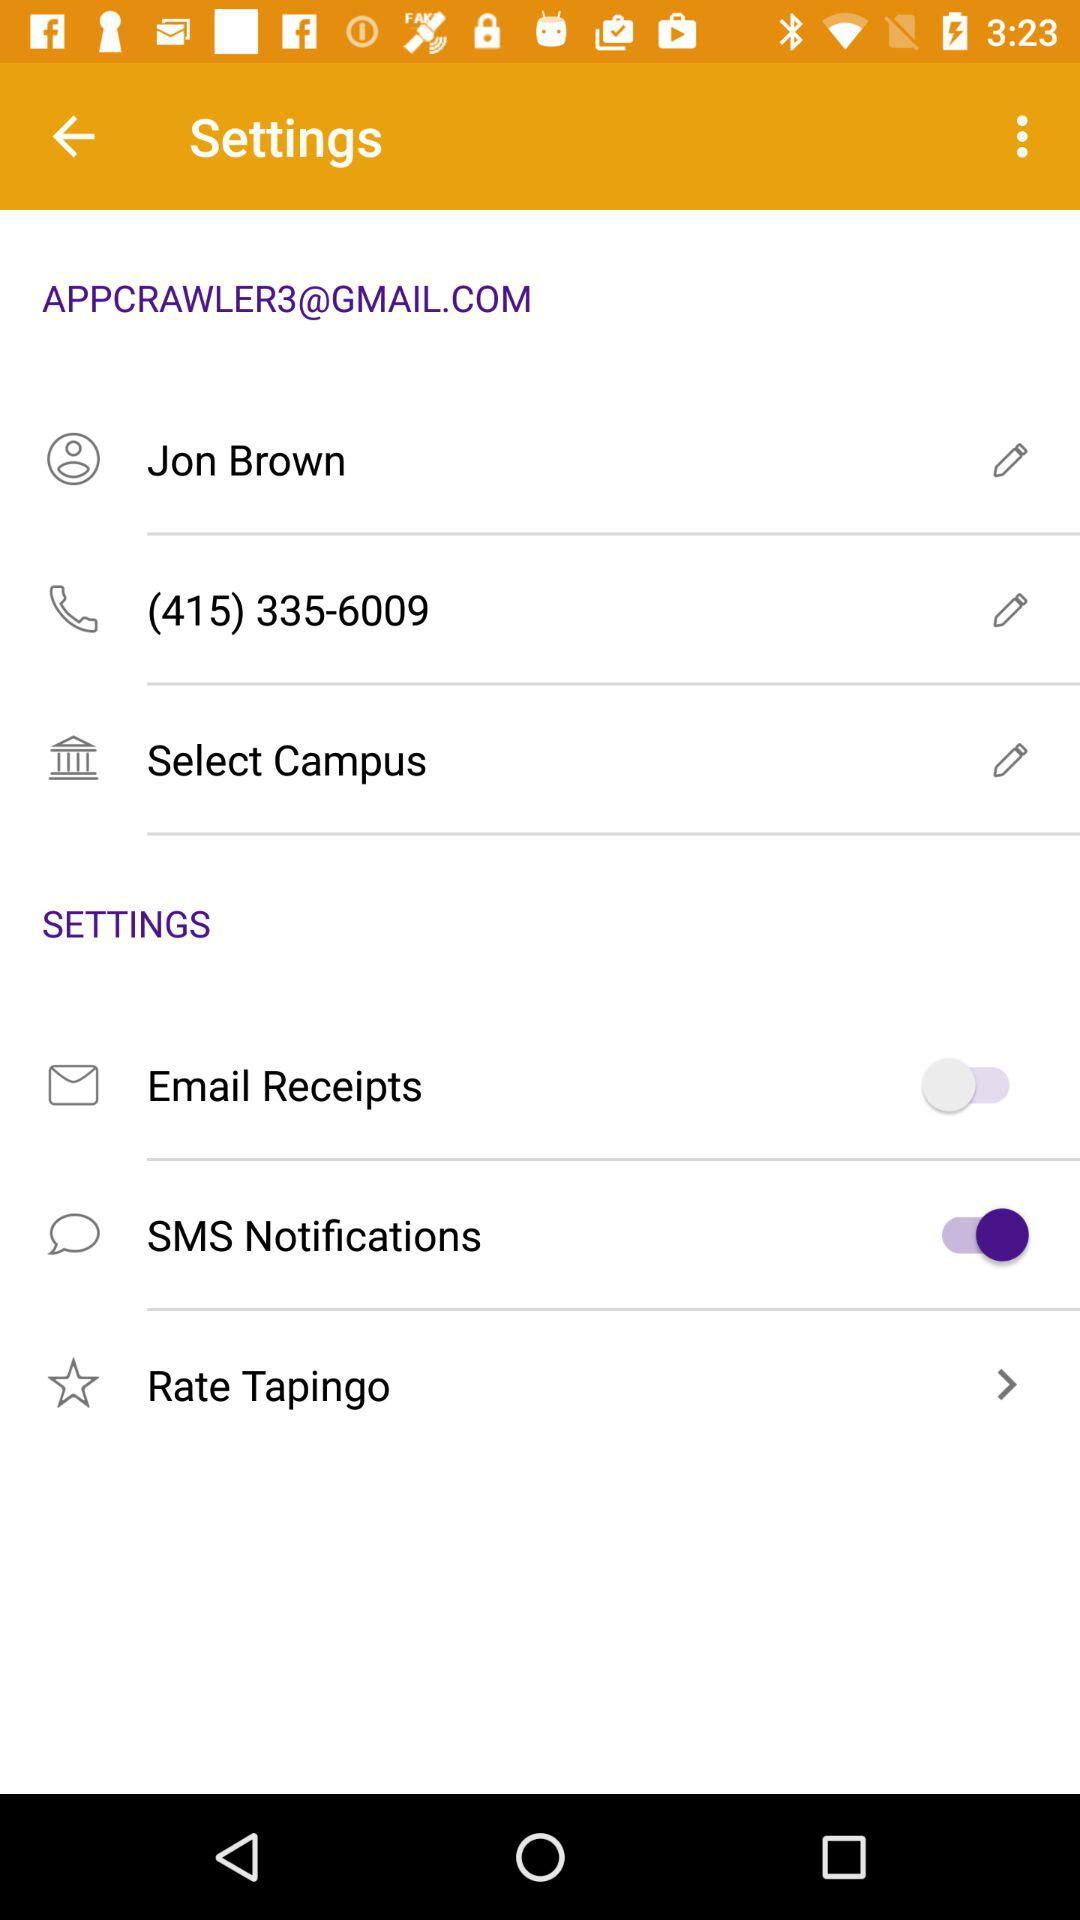What is the contact number? The contact number is (415) 335-6009. 